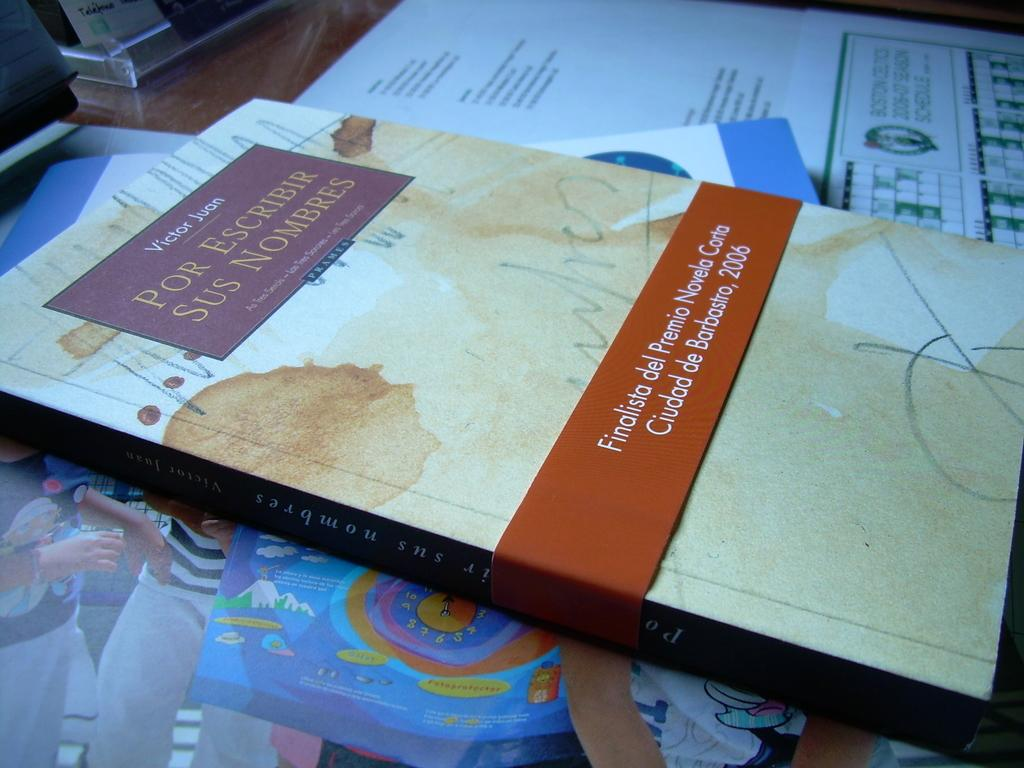<image>
Present a compact description of the photo's key features. A book by Victor Juan is stacked with other books on a desk. 